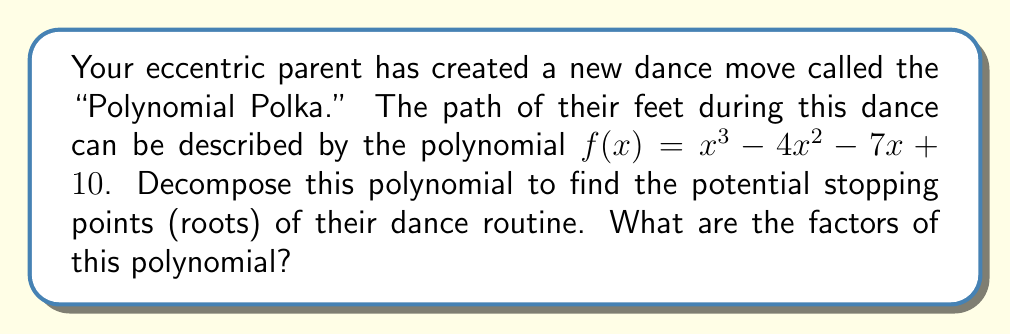Show me your answer to this math problem. Let's approach this step-by-step:

1) First, we need to check if there are any rational roots. We can use the rational root theorem. The possible rational roots are the factors of the constant term (10): ±1, ±2, ±5, ±10.

2) Testing these values, we find that f(1) = 0. So (x - 1) is a factor.

3) We can use polynomial long division to divide f(x) by (x - 1):

   $$\frac{x^3 - 4x^2 - 7x + 10}{x - 1} = x^2 - 3x - 10$$

4) Now we have: $f(x) = (x - 1)(x^2 - 3x - 10)$

5) We need to factor the quadratic term $x^2 - 3x - 10$. We can do this by finding two numbers that multiply to give -10 and add to give -3. These numbers are -5 and 2.

6) Therefore, $x^2 - 3x - 10 = (x - 5)(x + 2)$

7) Putting it all together, we get:

   $f(x) = (x - 1)(x - 5)(x + 2)$

This factorization represents the potential stopping points of the dance at x = 1, x = 5, and x = -2.
Answer: $(x - 1)(x - 5)(x + 2)$ 